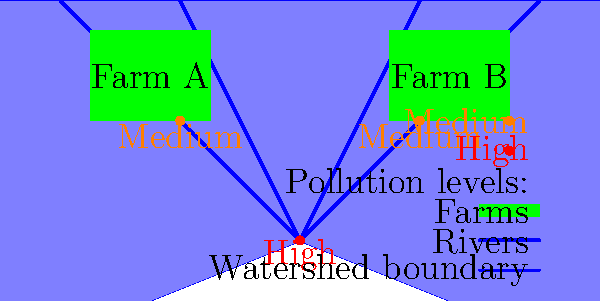Based on the watershed map provided, which farm is likely contributing more to the high pollution levels observed at the confluence of the two rivers, and why? To determine which farm is likely contributing more to the high pollution levels at the confluence of the rivers, we need to analyze the map and consider the following factors:

1. Location of farms:
   - Farm A is located in the upper left quadrant of the watershed.
   - Farm B is located in the upper right quadrant of the watershed.

2. River flow direction:
   - Both rivers flow from the edges of the watershed towards the center, meeting at a confluence point.

3. Pollution levels:
   - High pollution (red dot) is observed at the confluence of the two rivers.
   - Medium pollution (orange dots) is observed upstream from both farms.

4. Distance to confluence:
   - Farm A is slightly closer to the confluence point than Farm B.

5. Topography consideration:
   - The map suggests a general downward slope towards the confluence, as rivers typically flow downhill.

6. Runoff patterns:
   - Agricultural runoff would likely follow the topography and flow into the nearest river.

Analysis:
- Both farms show medium pollution levels in their immediate vicinity, indicating that they both contribute to water pollution.
- However, Farm A is positioned closer to the confluence and is upstream on a river that flows directly to the high pollution point.
- The runoff from Farm A has a more direct path to the confluence, with less distance for natural filtration or dilution to occur.
- While Farm B also contributes to pollution, its runoff has a longer path to the confluence, potentially allowing for more natural attenuation of pollutants.

Therefore, based on its proximity to the confluence and the more direct path of its runoff to the high pollution point, Farm A is likely contributing more to the high pollution levels observed at the confluence of the two rivers.
Answer: Farm A, due to closer proximity and more direct runoff path to the confluence. 